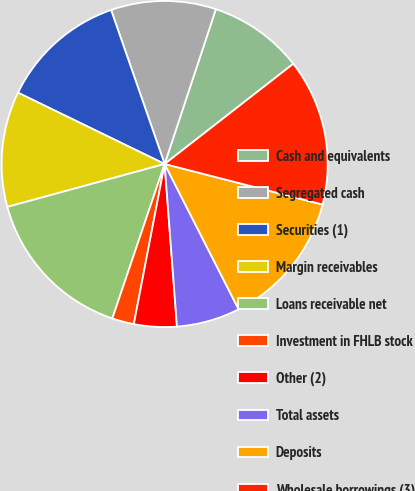<chart> <loc_0><loc_0><loc_500><loc_500><pie_chart><fcel>Cash and equivalents<fcel>Segregated cash<fcel>Securities (1)<fcel>Margin receivables<fcel>Loans receivable net<fcel>Investment in FHLB stock<fcel>Other (2)<fcel>Total assets<fcel>Deposits<fcel>Wholesale borrowings (3)<nl><fcel>9.38%<fcel>10.41%<fcel>12.47%<fcel>11.44%<fcel>15.56%<fcel>2.17%<fcel>4.23%<fcel>6.29%<fcel>13.5%<fcel>14.53%<nl></chart> 